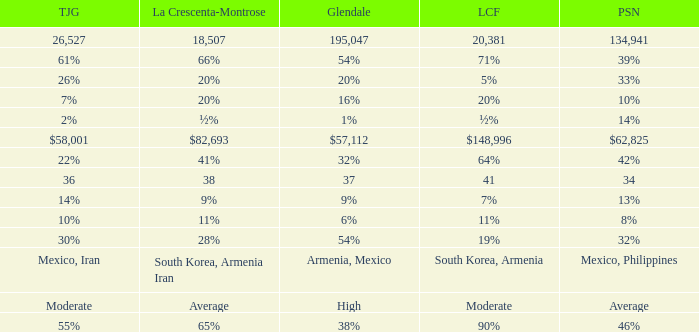Can you parse all the data within this table? {'header': ['TJG', 'La Crescenta-Montrose', 'Glendale', 'LCF', 'PSN'], 'rows': [['26,527', '18,507', '195,047', '20,381', '134,941'], ['61%', '66%', '54%', '71%', '39%'], ['26%', '20%', '20%', '5%', '33%'], ['7%', '20%', '16%', '20%', '10%'], ['2%', '½%', '1%', '½%', '14%'], ['$58,001', '$82,693', '$57,112', '$148,996', '$62,825'], ['22%', '41%', '32%', '64%', '42%'], ['36', '38', '37', '41', '34'], ['14%', '9%', '9%', '7%', '13%'], ['10%', '11%', '6%', '11%', '8%'], ['30%', '28%', '54%', '19%', '32%'], ['Mexico, Iran', 'South Korea, Armenia Iran', 'Armenia, Mexico', 'South Korea, Armenia', 'Mexico, Philippines'], ['Moderate', 'Average', 'High', 'Moderate', 'Average'], ['55%', '65%', '38%', '90%', '46%']]} What is the percentage of Glendale when Pasadena is 14%? 1%. 